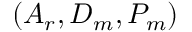<formula> <loc_0><loc_0><loc_500><loc_500>( A _ { r } , D _ { m } , P _ { m } )</formula> 